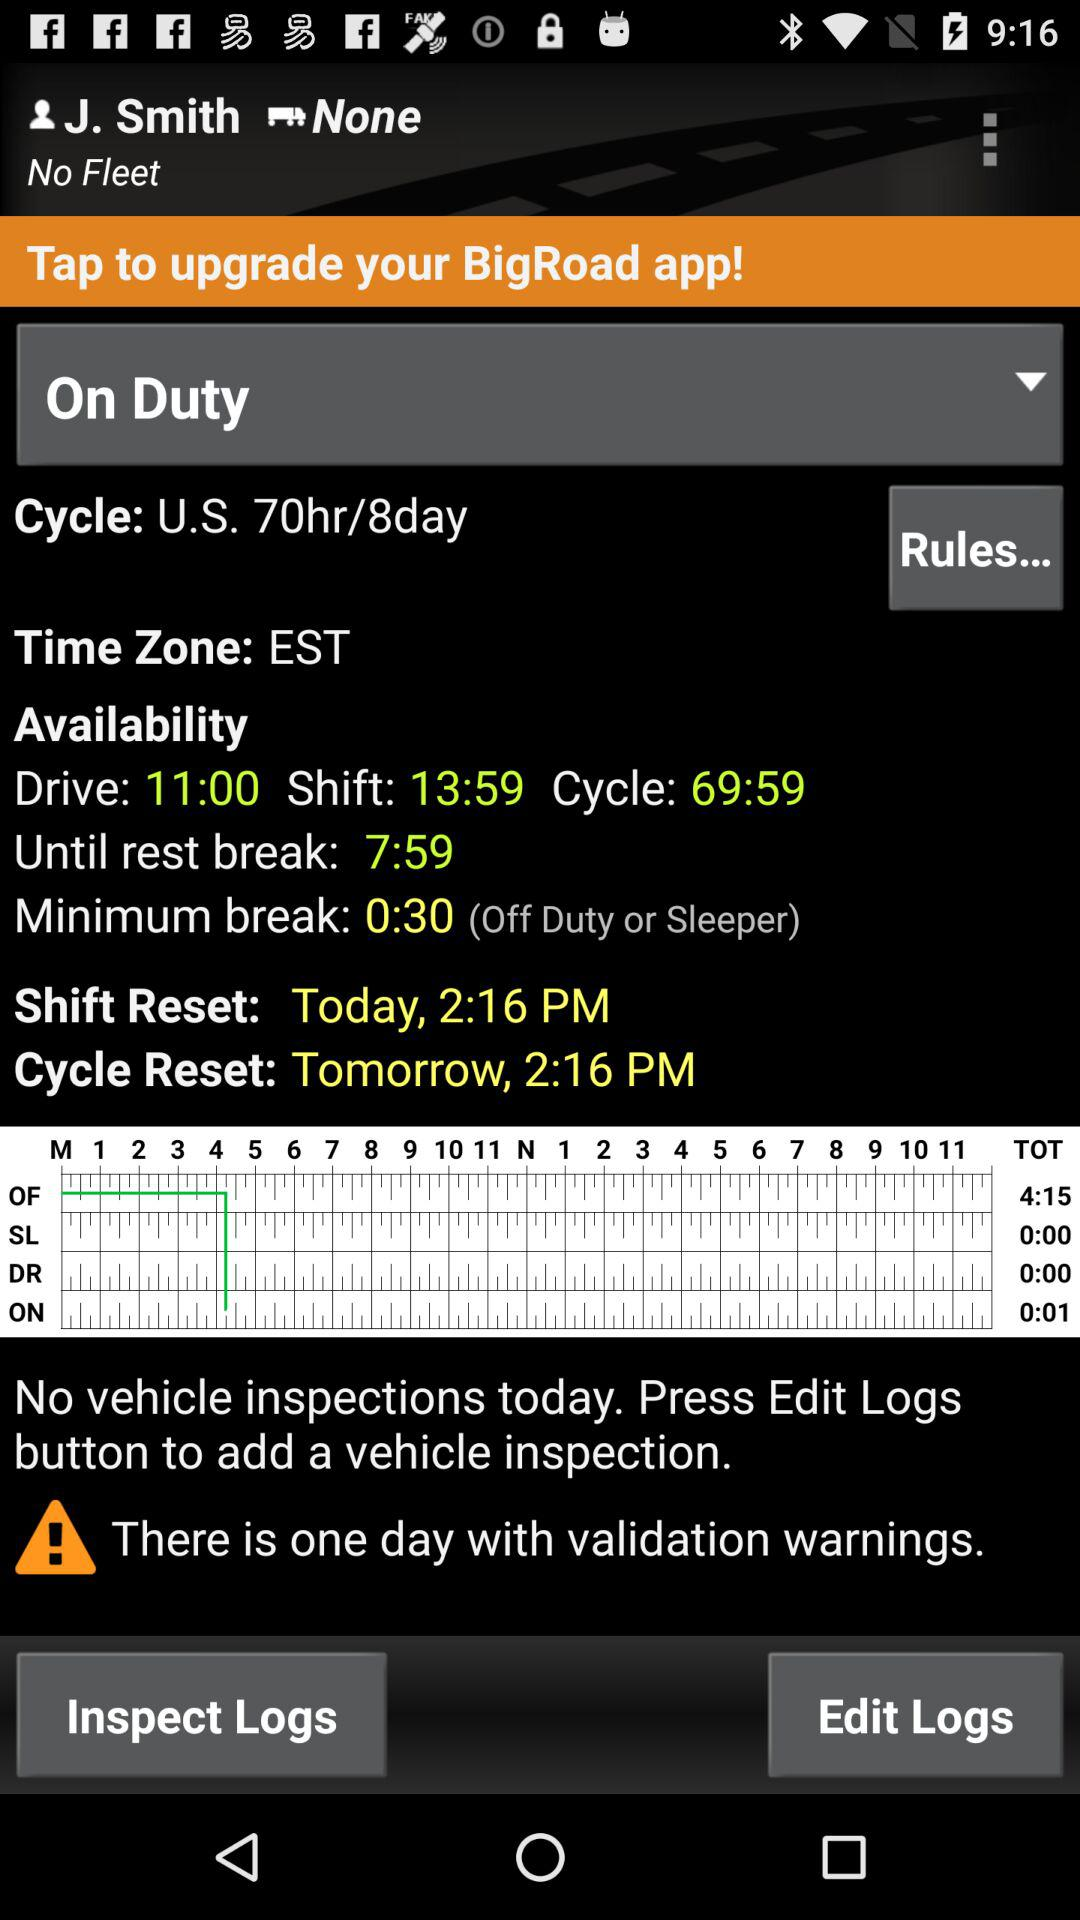What is the shift time? The shift time is 13:59. 